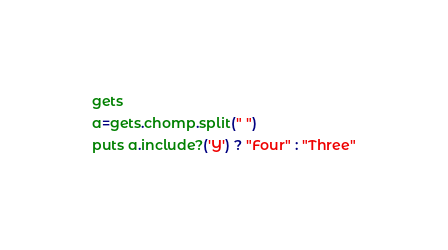Convert code to text. <code><loc_0><loc_0><loc_500><loc_500><_Ruby_>gets
a=gets.chomp.split(" ")
puts a.include?('Y') ? "Four" : "Three"</code> 